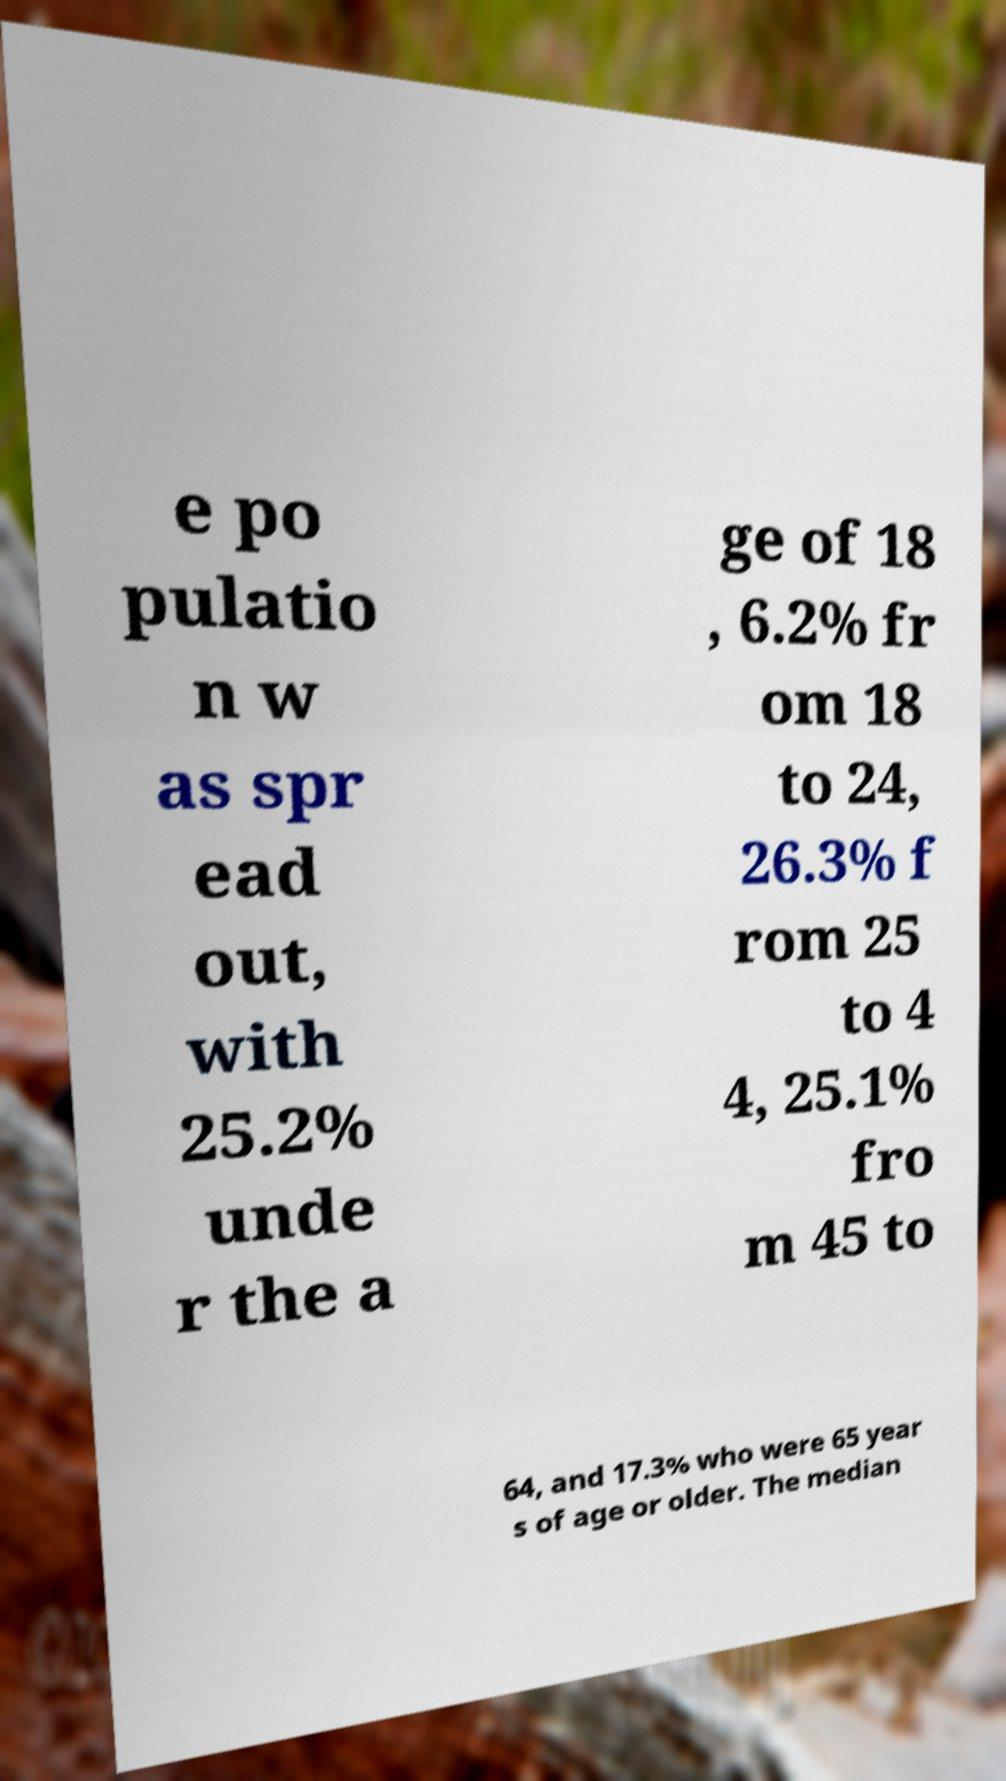Could you extract and type out the text from this image? e po pulatio n w as spr ead out, with 25.2% unde r the a ge of 18 , 6.2% fr om 18 to 24, 26.3% f rom 25 to 4 4, 25.1% fro m 45 to 64, and 17.3% who were 65 year s of age or older. The median 